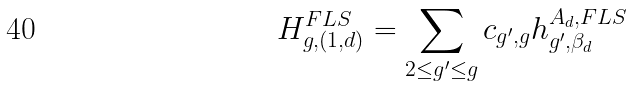Convert formula to latex. <formula><loc_0><loc_0><loc_500><loc_500>H ^ { F L S } _ { g , ( 1 , d ) } = \sum _ { 2 \leq g ^ { \prime } \leq g } c _ { g ^ { \prime } , g } h ^ { A _ { d } , F L S } _ { g ^ { \prime } , \beta _ { d } }</formula> 